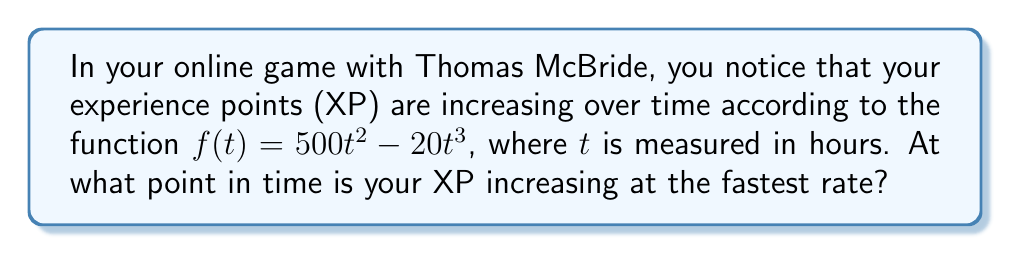Teach me how to tackle this problem. To find the point in time when the XP is increasing at the fastest rate, we need to follow these steps:

1) First, we need to find the rate of change of XP with respect to time. This is given by the first derivative of $f(t)$:

   $$f'(t) = 1000t - 60t^2$$

2) The fastest rate of increase will occur at the maximum value of $f'(t)$. To find this, we need to find where the derivative of $f'(t)$ equals zero:

   $$f''(t) = 1000 - 120t$$

3) Set $f''(t) = 0$ and solve for $t$:

   $$1000 - 120t = 0$$
   $$-120t = -1000$$
   $$t = \frac{1000}{120} = \frac{25}{3} \approx 8.33$$

4) To confirm this is a maximum (not a minimum), we can check that $f'''(t) = -120 < 0$, which indicates a concave down function at this point.

5) Therefore, the XP is increasing at the fastest rate when $t = \frac{25}{3}$ hours.

6) We can calculate the maximum rate of increase by plugging this value back into $f'(t)$:

   $$f'(\frac{25}{3}) = 1000(\frac{25}{3}) - 60(\frac{25}{3})^2 = \frac{25000}{3} - \frac{37500}{9} = \frac{37500}{9} \approx 4166.67$$
Answer: The XP is increasing at the fastest rate after $\frac{25}{3}$ hours (approximately 8.33 hours), and the maximum rate of increase is $\frac{37500}{9}$ XP per hour (approximately 4166.67 XP/hour). 